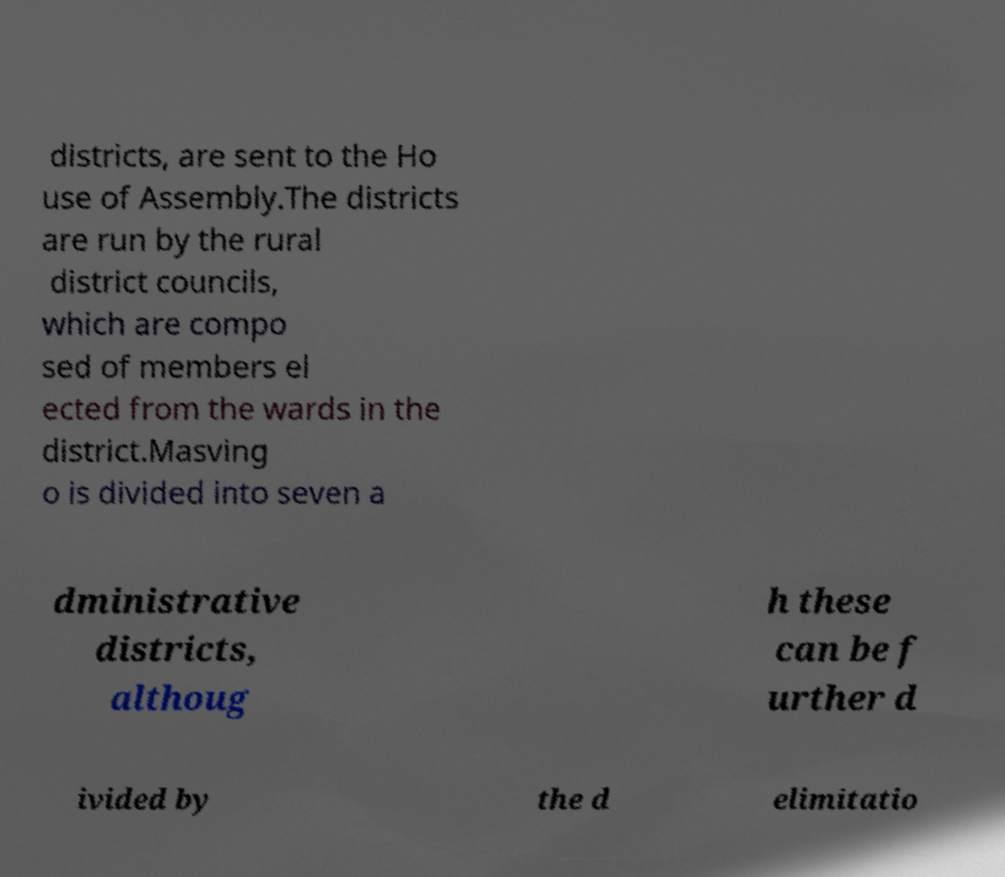Can you accurately transcribe the text from the provided image for me? districts, are sent to the Ho use of Assembly.The districts are run by the rural district councils, which are compo sed of members el ected from the wards in the district.Masving o is divided into seven a dministrative districts, althoug h these can be f urther d ivided by the d elimitatio 